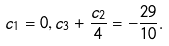Convert formula to latex. <formula><loc_0><loc_0><loc_500><loc_500>c _ { 1 } = 0 , c _ { 3 } + \frac { c _ { 2 } } { 4 } = - \frac { 2 9 } { 1 0 } .</formula> 